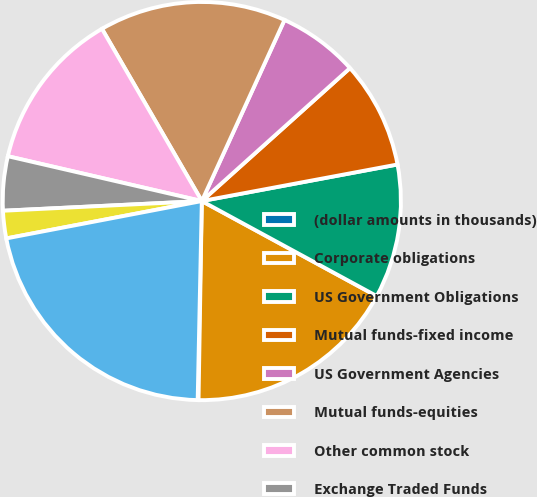<chart> <loc_0><loc_0><loc_500><loc_500><pie_chart><fcel>(dollar amounts in thousands)<fcel>Corporate obligations<fcel>US Government Obligations<fcel>Mutual funds-fixed income<fcel>US Government Agencies<fcel>Mutual funds-equities<fcel>Other common stock<fcel>Exchange Traded Funds<fcel>Limited Partnerships<fcel>Fair value of plan assets<nl><fcel>0.07%<fcel>17.34%<fcel>10.86%<fcel>8.7%<fcel>6.54%<fcel>15.18%<fcel>13.02%<fcel>4.39%<fcel>2.23%<fcel>21.66%<nl></chart> 